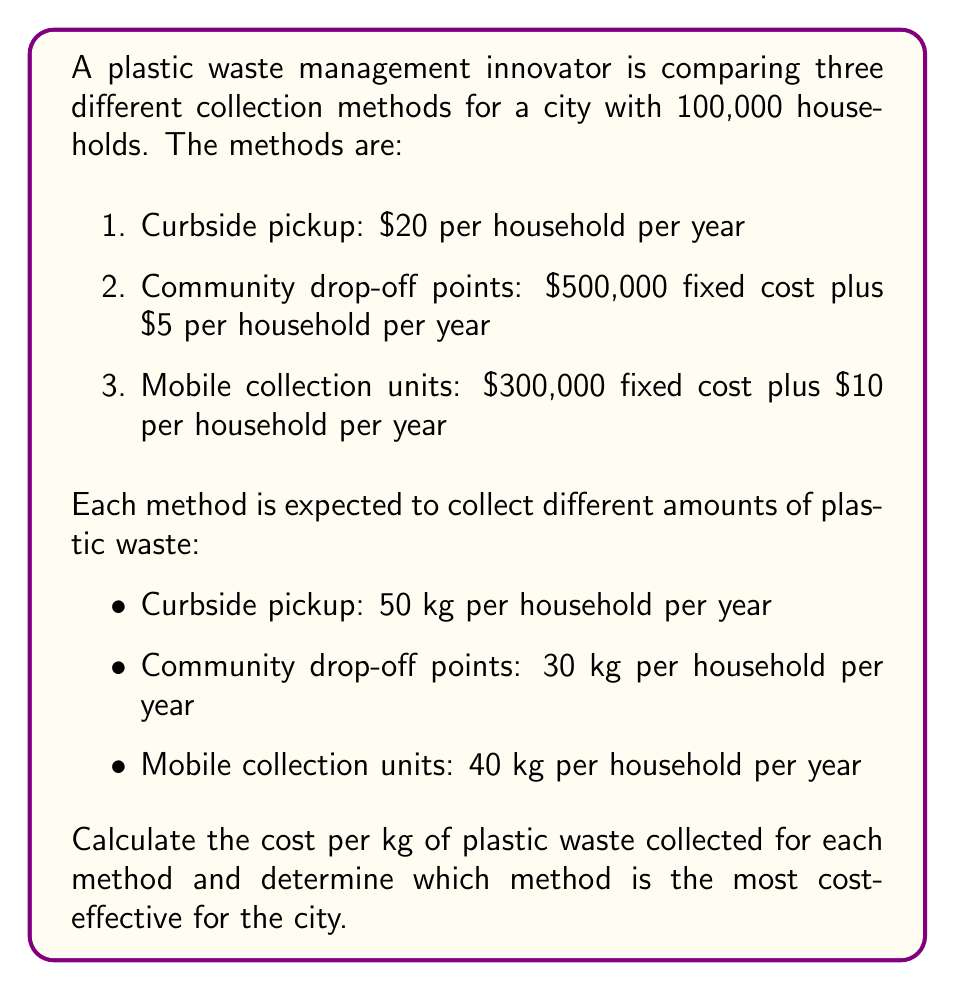Give your solution to this math problem. To solve this problem, we need to calculate the total cost and total plastic waste collected for each method, then divide the cost by the amount collected to find the cost per kg.

1. Curbside pickup:
   Total cost = $\$20 \times 100,000 = \$2,000,000$
   Total plastic collected = $50 \text{ kg} \times 100,000 = 5,000,000 \text{ kg}$
   Cost per kg = $\frac{\$2,000,000}{5,000,000 \text{ kg}} = \$0.40 \text{ per kg}$

2. Community drop-off points:
   Total cost = $\$500,000 + (\$5 \times 100,000) = \$1,000,000$
   Total plastic collected = $30 \text{ kg} \times 100,000 = 3,000,000 \text{ kg}$
   Cost per kg = $\frac{\$1,000,000}{3,000,000 \text{ kg}} = \$0.33 \text{ per kg}$

3. Mobile collection units:
   Total cost = $\$300,000 + (\$10 \times 100,000) = \$1,300,000$
   Total plastic collected = $40 \text{ kg} \times 100,000 = 4,000,000 \text{ kg}$
   Cost per kg = $\frac{\$1,300,000}{4,000,000 \text{ kg}} = \$0.325 \text{ per kg}$

Comparing the cost per kg for each method:
- Curbside pickup: $\$0.40 \text{ per kg}$
- Community drop-off points: $\$0.33 \text{ per kg}$
- Mobile collection units: $\$0.325 \text{ per kg}$

The most cost-effective method is the one with the lowest cost per kg of plastic waste collected.
Answer: The mobile collection units method is the most cost-effective, with a cost of $\$0.325 \text{ per kg}$ of plastic waste collected. 